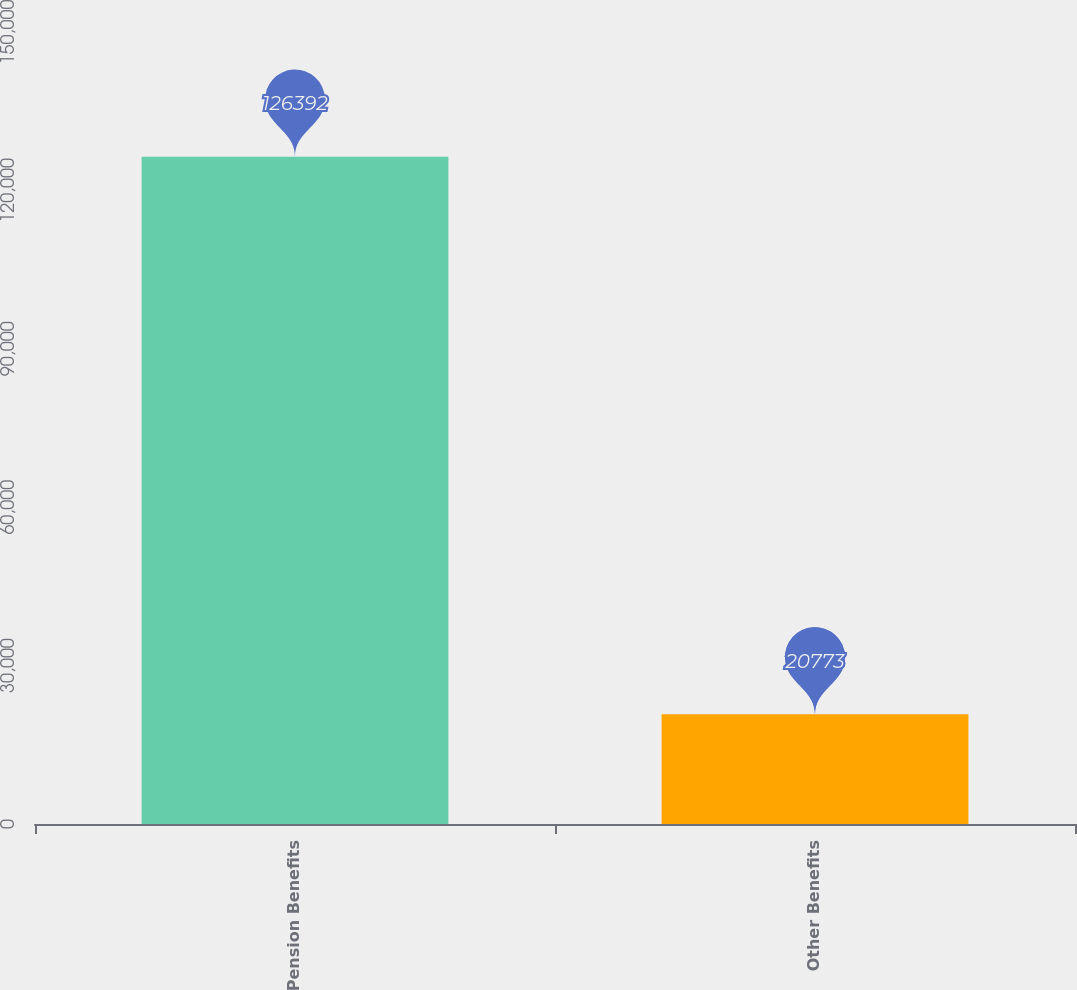Convert chart. <chart><loc_0><loc_0><loc_500><loc_500><bar_chart><fcel>Pension Benefits<fcel>Other Benefits<nl><fcel>126392<fcel>20773<nl></chart> 